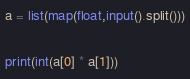<code> <loc_0><loc_0><loc_500><loc_500><_Python_>a = list(map(float,input().split()))

print(int(a[0] * a[1]))</code> 